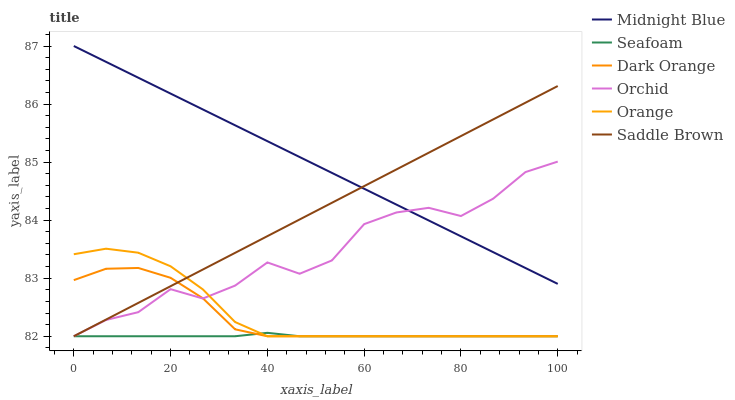Does Seafoam have the minimum area under the curve?
Answer yes or no. Yes. Does Midnight Blue have the maximum area under the curve?
Answer yes or no. Yes. Does Midnight Blue have the minimum area under the curve?
Answer yes or no. No. Does Seafoam have the maximum area under the curve?
Answer yes or no. No. Is Saddle Brown the smoothest?
Answer yes or no. Yes. Is Orchid the roughest?
Answer yes or no. Yes. Is Midnight Blue the smoothest?
Answer yes or no. No. Is Midnight Blue the roughest?
Answer yes or no. No. Does Dark Orange have the lowest value?
Answer yes or no. Yes. Does Midnight Blue have the lowest value?
Answer yes or no. No. Does Midnight Blue have the highest value?
Answer yes or no. Yes. Does Seafoam have the highest value?
Answer yes or no. No. Is Dark Orange less than Midnight Blue?
Answer yes or no. Yes. Is Midnight Blue greater than Dark Orange?
Answer yes or no. Yes. Does Orange intersect Orchid?
Answer yes or no. Yes. Is Orange less than Orchid?
Answer yes or no. No. Is Orange greater than Orchid?
Answer yes or no. No. Does Dark Orange intersect Midnight Blue?
Answer yes or no. No. 